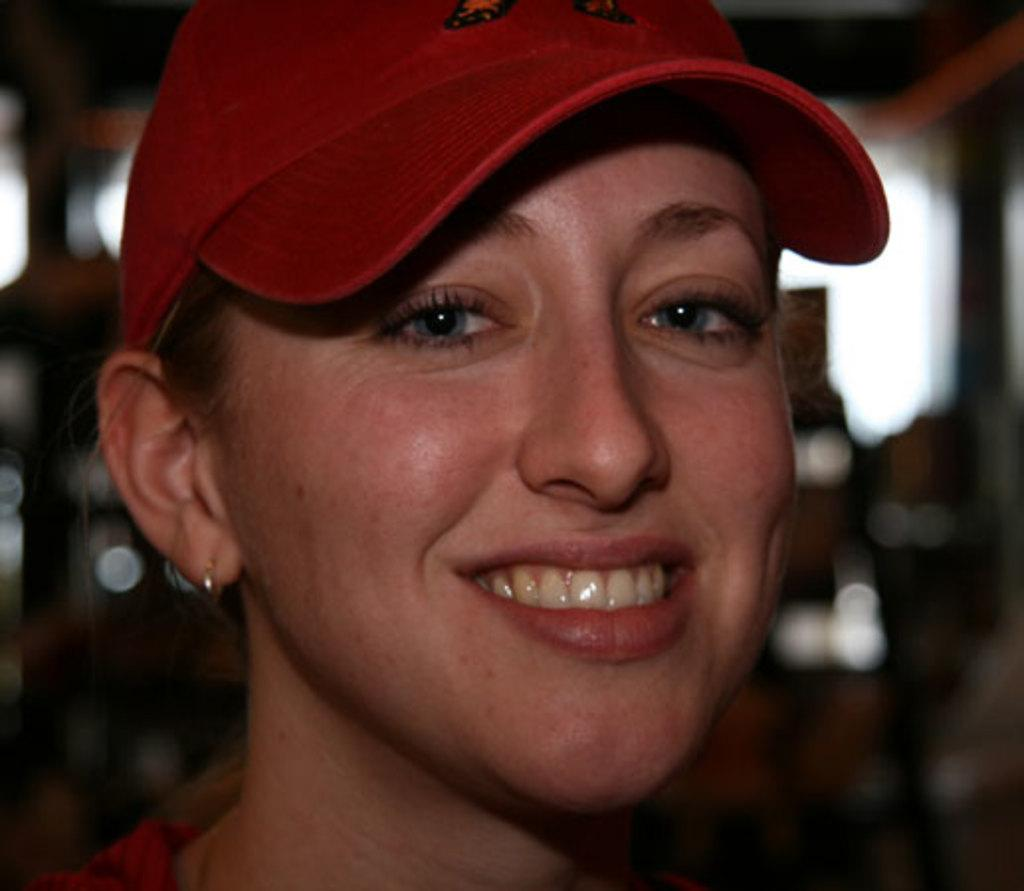What is the main subject of the image? The main subject of the image is a woman. What is the woman wearing on her head? The woman is wearing a red cap. What is the woman's facial expression in the image? The woman is smiling. What book is the woman holding in her hands in the image? There is no book visible in the image, and the woman's hands are not shown. 